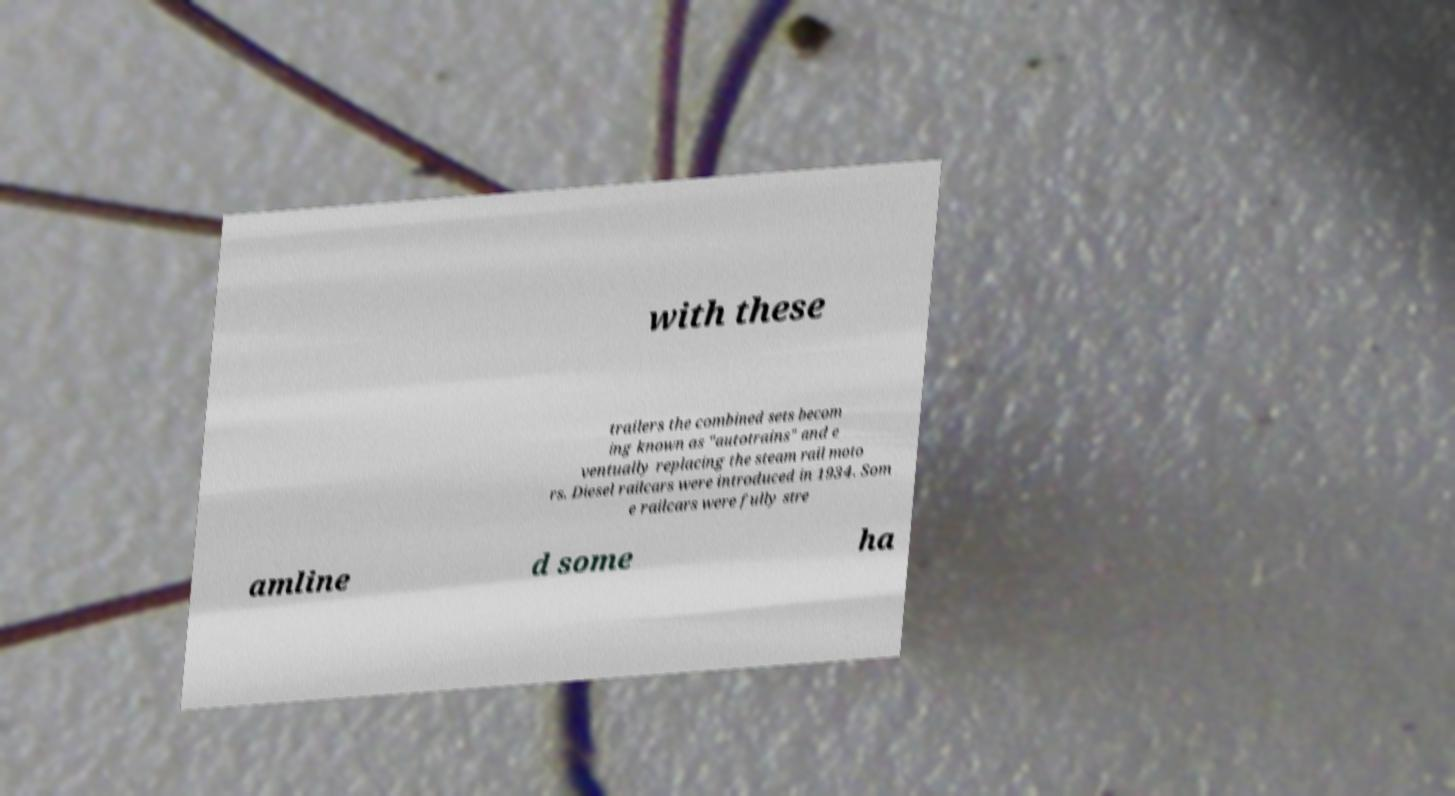Could you extract and type out the text from this image? with these trailers the combined sets becom ing known as "autotrains" and e ventually replacing the steam rail moto rs. Diesel railcars were introduced in 1934. Som e railcars were fully stre amline d some ha 